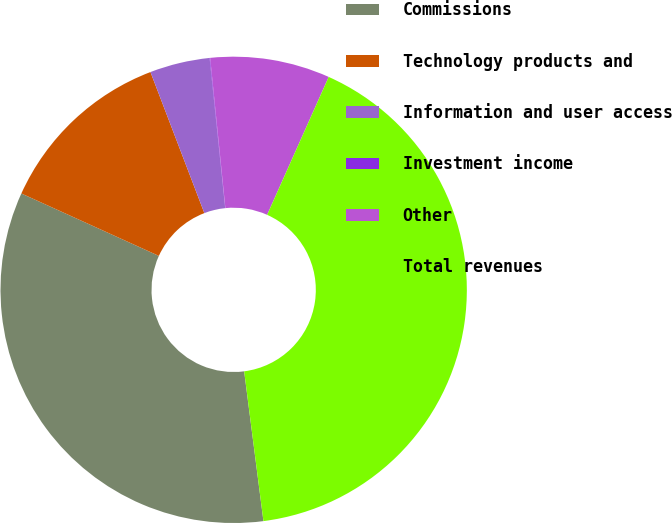Convert chart. <chart><loc_0><loc_0><loc_500><loc_500><pie_chart><fcel>Commissions<fcel>Technology products and<fcel>Information and user access<fcel>Investment income<fcel>Other<fcel>Total revenues<nl><fcel>33.82%<fcel>12.41%<fcel>4.16%<fcel>0.04%<fcel>8.29%<fcel>41.28%<nl></chart> 